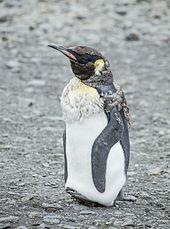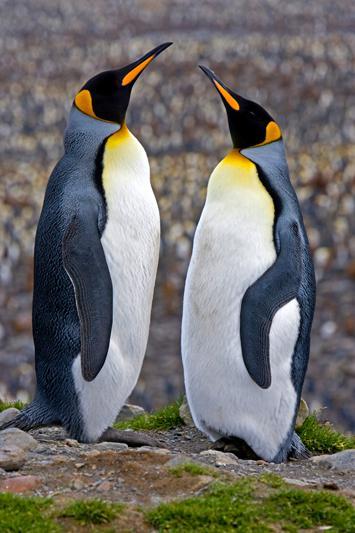The first image is the image on the left, the second image is the image on the right. Examine the images to the left and right. Is the description "There are exactly three penguins." accurate? Answer yes or no. Yes. The first image is the image on the left, the second image is the image on the right. Examine the images to the left and right. Is the description "2 penguins are facing each other with chests almost touching" accurate? Answer yes or no. Yes. 